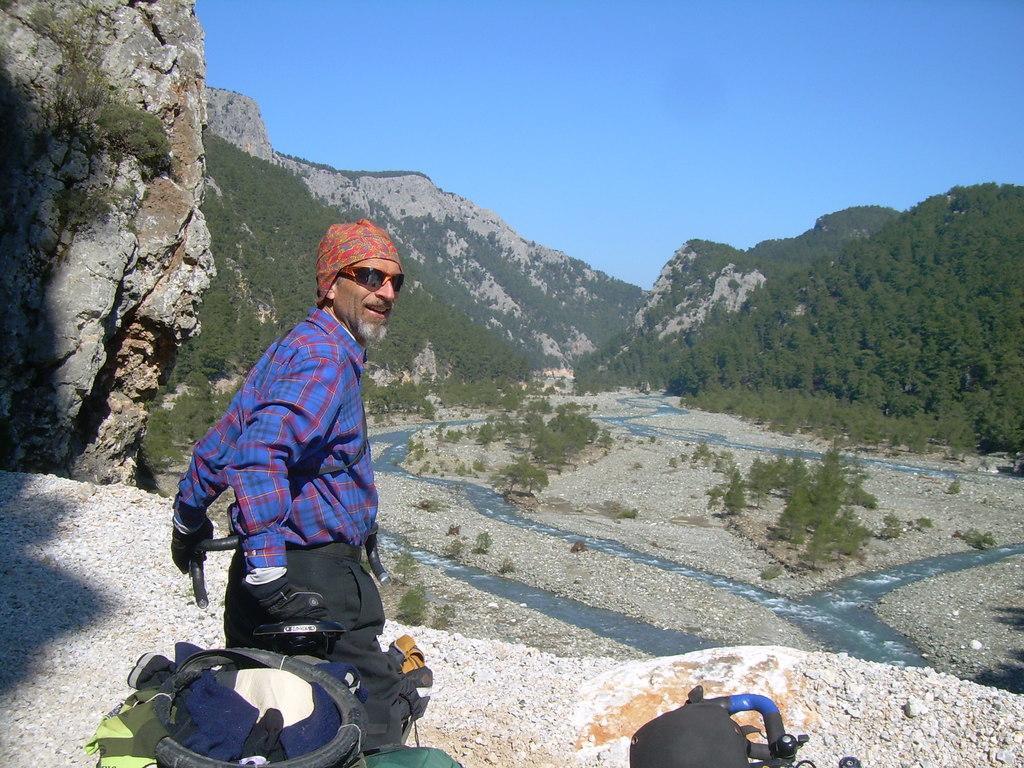How would you summarize this image in a sentence or two? In this image we can see a man standing on the hill. We can also see some stones and bags placed beside him. On the backside we can see some plants, a group of trees, water, the hills and the sky which looks cloudy. 